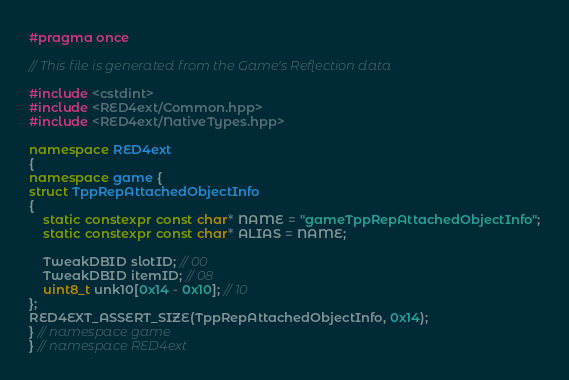Convert code to text. <code><loc_0><loc_0><loc_500><loc_500><_C++_>#pragma once

// This file is generated from the Game's Reflection data

#include <cstdint>
#include <RED4ext/Common.hpp>
#include <RED4ext/NativeTypes.hpp>

namespace RED4ext
{
namespace game { 
struct TppRepAttachedObjectInfo
{
    static constexpr const char* NAME = "gameTppRepAttachedObjectInfo";
    static constexpr const char* ALIAS = NAME;

    TweakDBID slotID; // 00
    TweakDBID itemID; // 08
    uint8_t unk10[0x14 - 0x10]; // 10
};
RED4EXT_ASSERT_SIZE(TppRepAttachedObjectInfo, 0x14);
} // namespace game
} // namespace RED4ext
</code> 